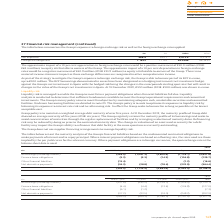According to Intu Properties's financial document, What is the average maturity of the Group debt in 2019? According to the financial document, five years. The relevant text states: "maintain a weighted average debt maturity of over five years. At 31 December 2019, the maturity profile of Group debt showed an average maturity of five years ( maintain a weighted average debt maturi..." Also, What is the average maturity of the Group debt in 2018? According to the financial document, six years. The relevant text states: "t showed an average maturity of five years (2018: six years). The Group regularly reviews the maturity profile of its borrowings and seeks to avoid concentrati..." Also, Why is liquidity analysis conducted? to determine that sufficient headroom is available to meet the Group’s operational requirements and committed investments.. The document states: "bilities fall due. Liquidity analysis is conducted to determine that sufficient headroom is available to meet the Group’s operational requirements and..." Also, can you calculate: What is the percentage change in the borrowings (including interest) that matures within 1 year from 2018 to 2019? To answer this question, I need to perform calculations using the financial data. The calculation is: (249.5-237.8)/237.8, which equals 4.92 (percentage). This is based on the information: "Borrowings (including interest) (249.5) (1,091.3) (2,600.9) (1,716.1) (5,657.8) Borrowings (including interest) (237.8) (245.2) (3,259.1) (2,408.0) (6,150.1)..." The key data points involved are: 237.8, 249.5. Also, can you calculate: What is the percentage of borrowings (including interest) that matures over 5 years in the total borrowings in 2019? Based on the calculation: 1,716.1/5,657.8, the result is 30.33 (percentage). This is based on the information: "interest) (249.5) (1,091.3) (2,600.9) (1,716.1) (5,657.8) (including interest) (249.5) (1,091.3) (2,600.9) (1,716.1) (5,657.8)..." The key data points involved are: 1,716.1, 5,657.8. Also, can you calculate: What is the percentage change in the total finance lease obligations from 2018 to 2019? To answer this question, I need to perform calculations using the financial data. The calculation is: (129.7-127.0)/127.0, which equals 2.13 (percentage). This is based on the information: "nce lease obligations (4.4) (4.4) (13.4) (104.8) (127.0) nce lease obligations (5.3) (5.3) (14.3) (104.8) (129.7)..." The key data points involved are: 127.0, 129.7. 